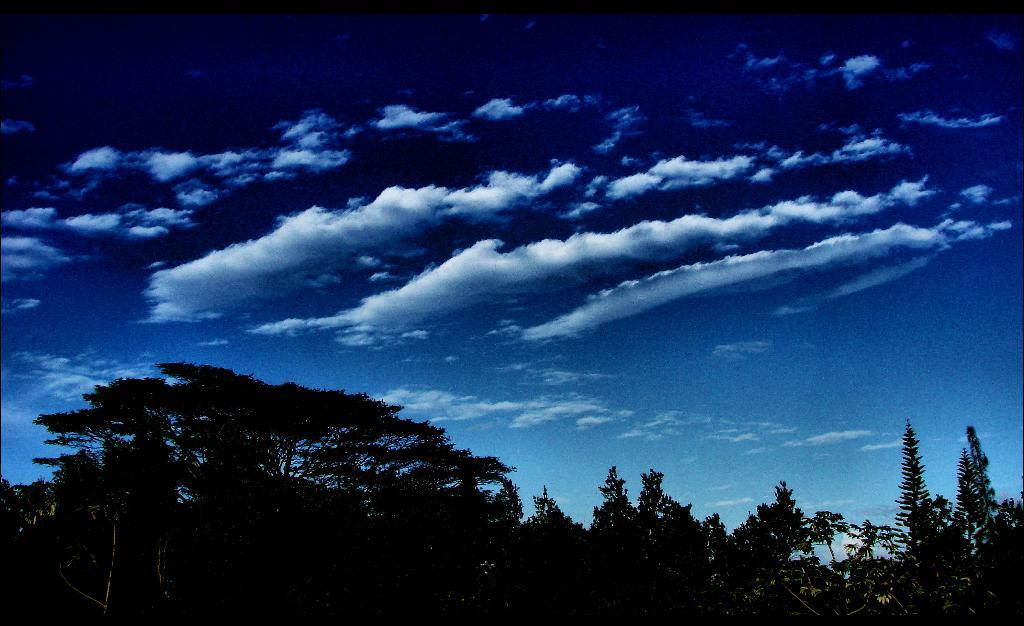What type of vegetation is at the bottom of the image? There are trees at the bottom of the image. What is visible at the top of the image? The sky is visible at the top of the image. Where is the shelf located in the image? There is no shelf present in the image. How many stars can be seen in the image? There is no star visible in the image; only trees and the sky are present. 